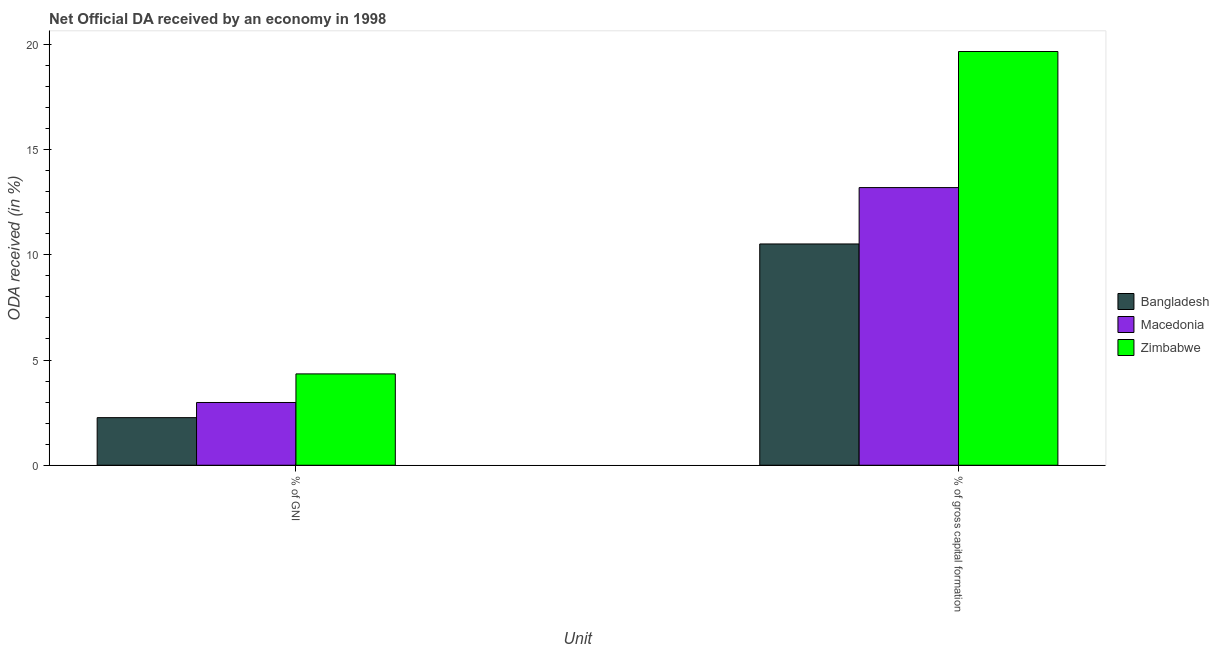How many groups of bars are there?
Offer a terse response. 2. Are the number of bars on each tick of the X-axis equal?
Your response must be concise. Yes. How many bars are there on the 2nd tick from the right?
Provide a short and direct response. 3. What is the label of the 2nd group of bars from the left?
Your answer should be compact. % of gross capital formation. What is the oda received as percentage of gni in Bangladesh?
Your response must be concise. 2.26. Across all countries, what is the maximum oda received as percentage of gni?
Your answer should be very brief. 4.34. Across all countries, what is the minimum oda received as percentage of gross capital formation?
Provide a succinct answer. 10.52. In which country was the oda received as percentage of gross capital formation maximum?
Your answer should be compact. Zimbabwe. In which country was the oda received as percentage of gross capital formation minimum?
Offer a very short reply. Bangladesh. What is the total oda received as percentage of gni in the graph?
Your response must be concise. 9.59. What is the difference between the oda received as percentage of gross capital formation in Macedonia and that in Bangladesh?
Your answer should be very brief. 2.68. What is the difference between the oda received as percentage of gni in Macedonia and the oda received as percentage of gross capital formation in Zimbabwe?
Your answer should be very brief. -16.68. What is the average oda received as percentage of gross capital formation per country?
Give a very brief answer. 14.46. What is the difference between the oda received as percentage of gni and oda received as percentage of gross capital formation in Zimbabwe?
Your answer should be compact. -15.32. In how many countries, is the oda received as percentage of gross capital formation greater than 15 %?
Offer a terse response. 1. What is the ratio of the oda received as percentage of gross capital formation in Bangladesh to that in Macedonia?
Provide a succinct answer. 0.8. Is the oda received as percentage of gross capital formation in Bangladesh less than that in Macedonia?
Keep it short and to the point. Yes. In how many countries, is the oda received as percentage of gni greater than the average oda received as percentage of gni taken over all countries?
Your answer should be compact. 1. What does the 2nd bar from the right in % of gross capital formation represents?
Your answer should be very brief. Macedonia. How many bars are there?
Provide a succinct answer. 6. How many countries are there in the graph?
Ensure brevity in your answer.  3. What is the difference between two consecutive major ticks on the Y-axis?
Give a very brief answer. 5. Does the graph contain grids?
Your answer should be very brief. No. How many legend labels are there?
Your response must be concise. 3. How are the legend labels stacked?
Your answer should be compact. Vertical. What is the title of the graph?
Your answer should be very brief. Net Official DA received by an economy in 1998. Does "Ecuador" appear as one of the legend labels in the graph?
Your answer should be compact. No. What is the label or title of the X-axis?
Provide a succinct answer. Unit. What is the label or title of the Y-axis?
Your response must be concise. ODA received (in %). What is the ODA received (in %) of Bangladesh in % of GNI?
Keep it short and to the point. 2.26. What is the ODA received (in %) of Macedonia in % of GNI?
Keep it short and to the point. 2.98. What is the ODA received (in %) of Zimbabwe in % of GNI?
Your answer should be very brief. 4.34. What is the ODA received (in %) in Bangladesh in % of gross capital formation?
Keep it short and to the point. 10.52. What is the ODA received (in %) of Macedonia in % of gross capital formation?
Offer a terse response. 13.2. What is the ODA received (in %) in Zimbabwe in % of gross capital formation?
Offer a very short reply. 19.66. Across all Unit, what is the maximum ODA received (in %) in Bangladesh?
Offer a very short reply. 10.52. Across all Unit, what is the maximum ODA received (in %) of Macedonia?
Keep it short and to the point. 13.2. Across all Unit, what is the maximum ODA received (in %) of Zimbabwe?
Offer a very short reply. 19.66. Across all Unit, what is the minimum ODA received (in %) in Bangladesh?
Ensure brevity in your answer.  2.26. Across all Unit, what is the minimum ODA received (in %) of Macedonia?
Give a very brief answer. 2.98. Across all Unit, what is the minimum ODA received (in %) in Zimbabwe?
Offer a very short reply. 4.34. What is the total ODA received (in %) in Bangladesh in the graph?
Ensure brevity in your answer.  12.78. What is the total ODA received (in %) in Macedonia in the graph?
Your answer should be very brief. 16.18. What is the total ODA received (in %) of Zimbabwe in the graph?
Your answer should be very brief. 24. What is the difference between the ODA received (in %) of Bangladesh in % of GNI and that in % of gross capital formation?
Provide a succinct answer. -8.26. What is the difference between the ODA received (in %) in Macedonia in % of GNI and that in % of gross capital formation?
Your answer should be very brief. -10.21. What is the difference between the ODA received (in %) in Zimbabwe in % of GNI and that in % of gross capital formation?
Keep it short and to the point. -15.32. What is the difference between the ODA received (in %) of Bangladesh in % of GNI and the ODA received (in %) of Macedonia in % of gross capital formation?
Keep it short and to the point. -10.93. What is the difference between the ODA received (in %) in Bangladesh in % of GNI and the ODA received (in %) in Zimbabwe in % of gross capital formation?
Keep it short and to the point. -17.4. What is the difference between the ODA received (in %) of Macedonia in % of GNI and the ODA received (in %) of Zimbabwe in % of gross capital formation?
Provide a short and direct response. -16.68. What is the average ODA received (in %) of Bangladesh per Unit?
Offer a very short reply. 6.39. What is the average ODA received (in %) of Macedonia per Unit?
Keep it short and to the point. 8.09. What is the average ODA received (in %) in Zimbabwe per Unit?
Make the answer very short. 12. What is the difference between the ODA received (in %) in Bangladesh and ODA received (in %) in Macedonia in % of GNI?
Ensure brevity in your answer.  -0.72. What is the difference between the ODA received (in %) of Bangladesh and ODA received (in %) of Zimbabwe in % of GNI?
Offer a terse response. -2.08. What is the difference between the ODA received (in %) of Macedonia and ODA received (in %) of Zimbabwe in % of GNI?
Your response must be concise. -1.36. What is the difference between the ODA received (in %) of Bangladesh and ODA received (in %) of Macedonia in % of gross capital formation?
Offer a terse response. -2.68. What is the difference between the ODA received (in %) in Bangladesh and ODA received (in %) in Zimbabwe in % of gross capital formation?
Your answer should be compact. -9.15. What is the difference between the ODA received (in %) of Macedonia and ODA received (in %) of Zimbabwe in % of gross capital formation?
Provide a succinct answer. -6.47. What is the ratio of the ODA received (in %) of Bangladesh in % of GNI to that in % of gross capital formation?
Your answer should be compact. 0.22. What is the ratio of the ODA received (in %) in Macedonia in % of GNI to that in % of gross capital formation?
Offer a very short reply. 0.23. What is the ratio of the ODA received (in %) of Zimbabwe in % of GNI to that in % of gross capital formation?
Provide a succinct answer. 0.22. What is the difference between the highest and the second highest ODA received (in %) in Bangladesh?
Provide a short and direct response. 8.26. What is the difference between the highest and the second highest ODA received (in %) of Macedonia?
Your answer should be compact. 10.21. What is the difference between the highest and the second highest ODA received (in %) in Zimbabwe?
Give a very brief answer. 15.32. What is the difference between the highest and the lowest ODA received (in %) in Bangladesh?
Ensure brevity in your answer.  8.26. What is the difference between the highest and the lowest ODA received (in %) in Macedonia?
Give a very brief answer. 10.21. What is the difference between the highest and the lowest ODA received (in %) in Zimbabwe?
Offer a very short reply. 15.32. 